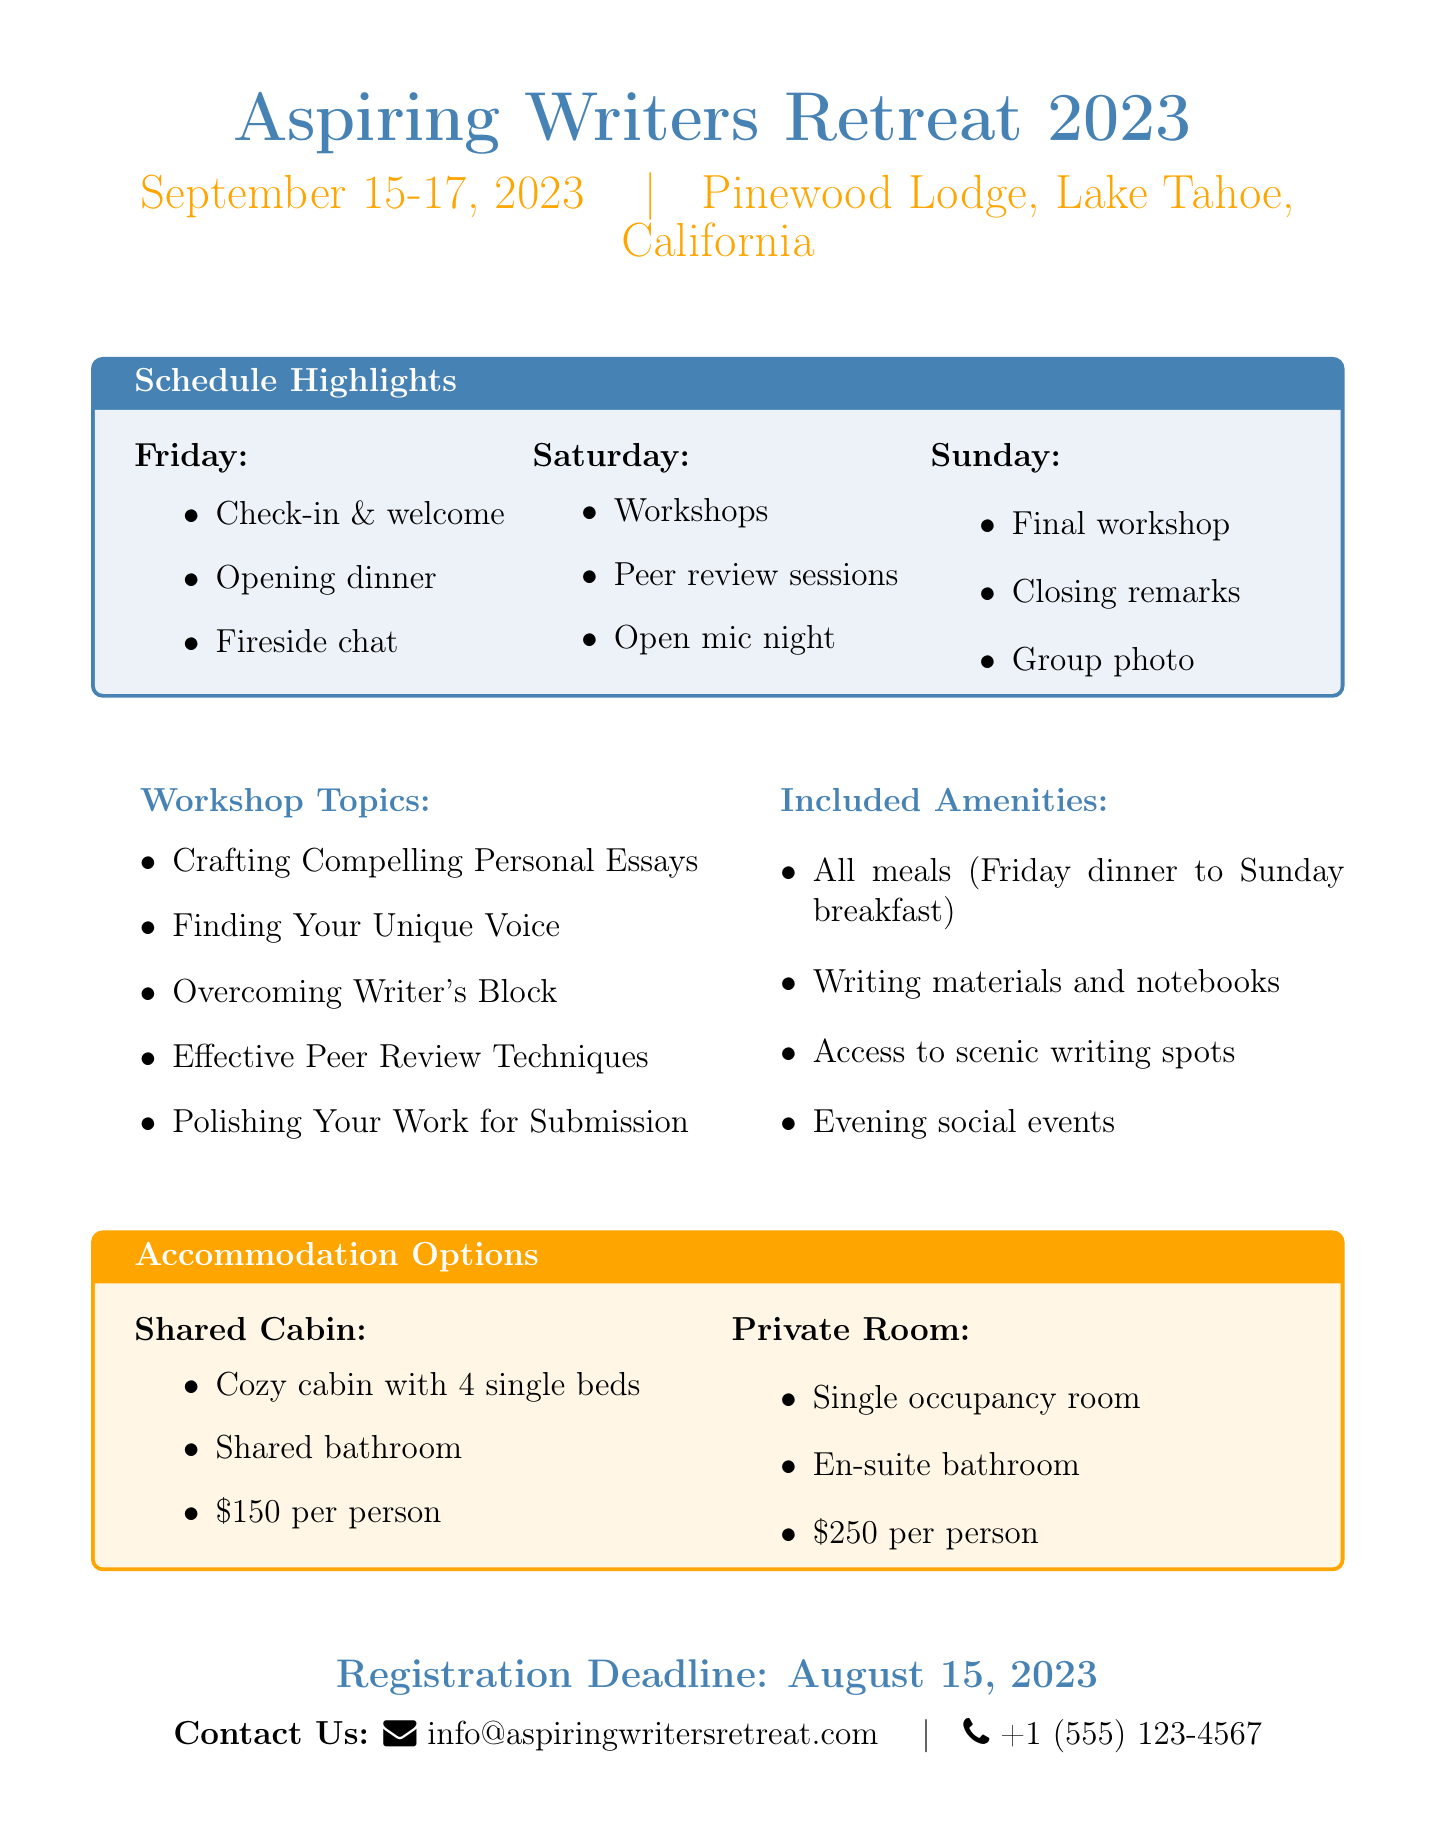What are the dates of the retreat? The dates of the retreat can be found in the header of the document, which states September 15-17, 2023.
Answer: September 15-17, 2023 Where is the retreat located? The location of the retreat is given in the header of the document, which mentions Pinewood Lodge, Lake Tahoe, California.
Answer: Pinewood Lodge, Lake Tahoe, California Who is leading the workshop on Saturday at 9:30 AM? The document specifies that the workshop at that time is led by Roxane Gay, as listed in the Saturday schedule.
Answer: Roxane Gay What is the price for a Shared Cabin? The document details accommodation options, explicitly stating the price for a Shared Cabin is $150 per person.
Answer: $150 per person What amenities are included with the retreat? The document lists included amenities such as meals, writing materials, scenic spots, and social events.
Answer: All meals, writing materials, access to scenic spots, evening social events What workshop topic is scheduled for Sunday at 9:30 AM? The schedule section outlines that the workshop at that time is about "Polishing Your Work for Submission."
Answer: Polishing Your Work for Submission What time does check-out occur on Sunday? The check-out time is provided in the Sunday schedule, which states it is at 12:00 PM.
Answer: 12:00 PM What is the registration deadline? The document clearly states the registration deadline is August 15, 2023.
Answer: August 15, 2023 How many beds are in the Shared Cabin? The document describes the Shared Cabin accommodation as having 4 single beds.
Answer: 4 single beds 